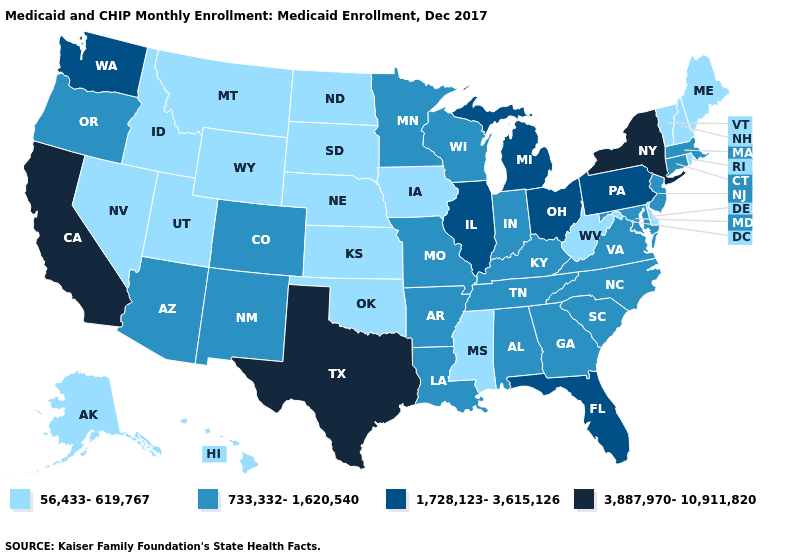Among the states that border Maryland , does Delaware have the highest value?
Write a very short answer. No. Name the states that have a value in the range 1,728,123-3,615,126?
Quick response, please. Florida, Illinois, Michigan, Ohio, Pennsylvania, Washington. Name the states that have a value in the range 733,332-1,620,540?
Quick response, please. Alabama, Arizona, Arkansas, Colorado, Connecticut, Georgia, Indiana, Kentucky, Louisiana, Maryland, Massachusetts, Minnesota, Missouri, New Jersey, New Mexico, North Carolina, Oregon, South Carolina, Tennessee, Virginia, Wisconsin. Does Hawaii have the same value as Michigan?
Quick response, please. No. Name the states that have a value in the range 1,728,123-3,615,126?
Short answer required. Florida, Illinois, Michigan, Ohio, Pennsylvania, Washington. Does Illinois have the same value as Michigan?
Quick response, please. Yes. Which states have the highest value in the USA?
Give a very brief answer. California, New York, Texas. Does New Jersey have a higher value than Utah?
Give a very brief answer. Yes. What is the value of Mississippi?
Give a very brief answer. 56,433-619,767. What is the lowest value in the USA?
Write a very short answer. 56,433-619,767. Does Nevada have the lowest value in the USA?
Be succinct. Yes. Does Utah have a higher value than Oklahoma?
Write a very short answer. No. What is the value of Maine?
Quick response, please. 56,433-619,767. What is the value of Hawaii?
Give a very brief answer. 56,433-619,767. 